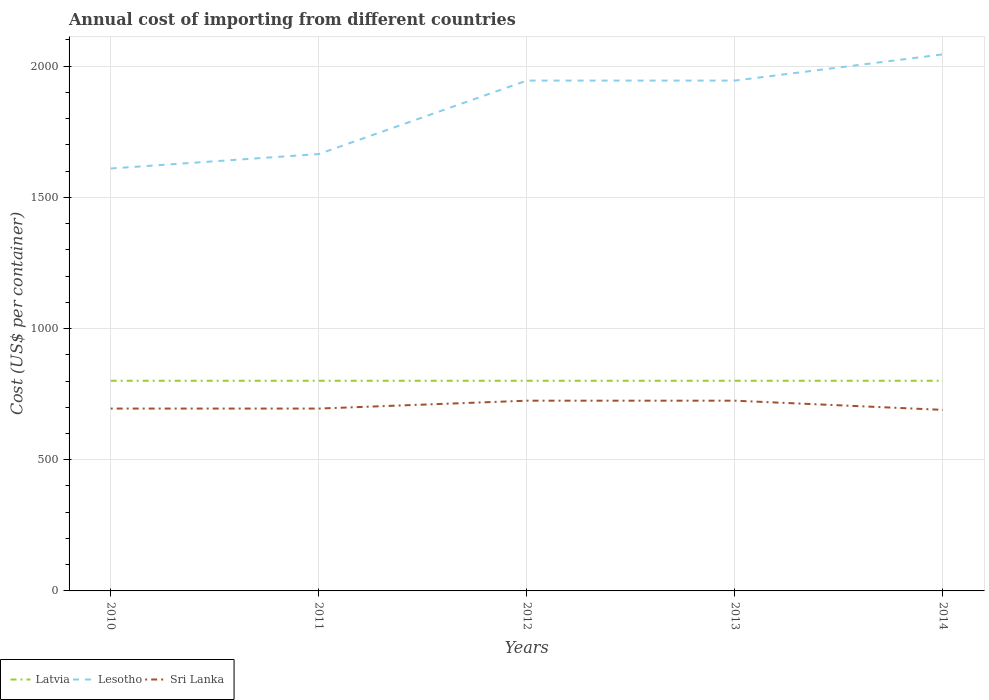How many different coloured lines are there?
Keep it short and to the point. 3. Across all years, what is the maximum total annual cost of importing in Latvia?
Your answer should be very brief. 801. What is the total total annual cost of importing in Sri Lanka in the graph?
Offer a terse response. 35. What is the difference between the highest and the second highest total annual cost of importing in Lesotho?
Your answer should be compact. 435. How many lines are there?
Make the answer very short. 3. Does the graph contain any zero values?
Your response must be concise. No. Where does the legend appear in the graph?
Give a very brief answer. Bottom left. How are the legend labels stacked?
Keep it short and to the point. Horizontal. What is the title of the graph?
Offer a terse response. Annual cost of importing from different countries. What is the label or title of the X-axis?
Provide a succinct answer. Years. What is the label or title of the Y-axis?
Your answer should be very brief. Cost (US$ per container). What is the Cost (US$ per container) of Latvia in 2010?
Provide a succinct answer. 801. What is the Cost (US$ per container) of Lesotho in 2010?
Keep it short and to the point. 1610. What is the Cost (US$ per container) in Sri Lanka in 2010?
Provide a short and direct response. 695. What is the Cost (US$ per container) of Latvia in 2011?
Make the answer very short. 801. What is the Cost (US$ per container) in Lesotho in 2011?
Provide a short and direct response. 1665. What is the Cost (US$ per container) of Sri Lanka in 2011?
Your response must be concise. 695. What is the Cost (US$ per container) in Latvia in 2012?
Your response must be concise. 801. What is the Cost (US$ per container) in Lesotho in 2012?
Your answer should be compact. 1945. What is the Cost (US$ per container) in Sri Lanka in 2012?
Ensure brevity in your answer.  725. What is the Cost (US$ per container) in Latvia in 2013?
Provide a short and direct response. 801. What is the Cost (US$ per container) of Lesotho in 2013?
Your response must be concise. 1945. What is the Cost (US$ per container) of Sri Lanka in 2013?
Ensure brevity in your answer.  725. What is the Cost (US$ per container) of Latvia in 2014?
Make the answer very short. 801. What is the Cost (US$ per container) of Lesotho in 2014?
Offer a terse response. 2045. What is the Cost (US$ per container) of Sri Lanka in 2014?
Keep it short and to the point. 690. Across all years, what is the maximum Cost (US$ per container) in Latvia?
Provide a succinct answer. 801. Across all years, what is the maximum Cost (US$ per container) of Lesotho?
Your answer should be compact. 2045. Across all years, what is the maximum Cost (US$ per container) of Sri Lanka?
Offer a very short reply. 725. Across all years, what is the minimum Cost (US$ per container) of Latvia?
Ensure brevity in your answer.  801. Across all years, what is the minimum Cost (US$ per container) of Lesotho?
Keep it short and to the point. 1610. Across all years, what is the minimum Cost (US$ per container) in Sri Lanka?
Provide a short and direct response. 690. What is the total Cost (US$ per container) in Latvia in the graph?
Keep it short and to the point. 4005. What is the total Cost (US$ per container) in Lesotho in the graph?
Ensure brevity in your answer.  9210. What is the total Cost (US$ per container) of Sri Lanka in the graph?
Your response must be concise. 3530. What is the difference between the Cost (US$ per container) in Lesotho in 2010 and that in 2011?
Make the answer very short. -55. What is the difference between the Cost (US$ per container) of Lesotho in 2010 and that in 2012?
Make the answer very short. -335. What is the difference between the Cost (US$ per container) in Sri Lanka in 2010 and that in 2012?
Make the answer very short. -30. What is the difference between the Cost (US$ per container) in Latvia in 2010 and that in 2013?
Offer a terse response. 0. What is the difference between the Cost (US$ per container) in Lesotho in 2010 and that in 2013?
Offer a terse response. -335. What is the difference between the Cost (US$ per container) of Sri Lanka in 2010 and that in 2013?
Your answer should be compact. -30. What is the difference between the Cost (US$ per container) in Latvia in 2010 and that in 2014?
Provide a short and direct response. 0. What is the difference between the Cost (US$ per container) of Lesotho in 2010 and that in 2014?
Keep it short and to the point. -435. What is the difference between the Cost (US$ per container) of Sri Lanka in 2010 and that in 2014?
Give a very brief answer. 5. What is the difference between the Cost (US$ per container) of Latvia in 2011 and that in 2012?
Provide a short and direct response. 0. What is the difference between the Cost (US$ per container) of Lesotho in 2011 and that in 2012?
Your answer should be very brief. -280. What is the difference between the Cost (US$ per container) of Sri Lanka in 2011 and that in 2012?
Your answer should be very brief. -30. What is the difference between the Cost (US$ per container) in Lesotho in 2011 and that in 2013?
Provide a succinct answer. -280. What is the difference between the Cost (US$ per container) in Latvia in 2011 and that in 2014?
Make the answer very short. 0. What is the difference between the Cost (US$ per container) in Lesotho in 2011 and that in 2014?
Keep it short and to the point. -380. What is the difference between the Cost (US$ per container) in Sri Lanka in 2011 and that in 2014?
Your answer should be very brief. 5. What is the difference between the Cost (US$ per container) in Latvia in 2012 and that in 2013?
Offer a very short reply. 0. What is the difference between the Cost (US$ per container) in Lesotho in 2012 and that in 2013?
Your response must be concise. 0. What is the difference between the Cost (US$ per container) in Latvia in 2012 and that in 2014?
Make the answer very short. 0. What is the difference between the Cost (US$ per container) of Lesotho in 2012 and that in 2014?
Ensure brevity in your answer.  -100. What is the difference between the Cost (US$ per container) in Sri Lanka in 2012 and that in 2014?
Your answer should be very brief. 35. What is the difference between the Cost (US$ per container) of Latvia in 2013 and that in 2014?
Provide a succinct answer. 0. What is the difference between the Cost (US$ per container) of Lesotho in 2013 and that in 2014?
Give a very brief answer. -100. What is the difference between the Cost (US$ per container) in Latvia in 2010 and the Cost (US$ per container) in Lesotho in 2011?
Provide a succinct answer. -864. What is the difference between the Cost (US$ per container) of Latvia in 2010 and the Cost (US$ per container) of Sri Lanka in 2011?
Ensure brevity in your answer.  106. What is the difference between the Cost (US$ per container) of Lesotho in 2010 and the Cost (US$ per container) of Sri Lanka in 2011?
Provide a succinct answer. 915. What is the difference between the Cost (US$ per container) in Latvia in 2010 and the Cost (US$ per container) in Lesotho in 2012?
Offer a very short reply. -1144. What is the difference between the Cost (US$ per container) in Latvia in 2010 and the Cost (US$ per container) in Sri Lanka in 2012?
Give a very brief answer. 76. What is the difference between the Cost (US$ per container) in Lesotho in 2010 and the Cost (US$ per container) in Sri Lanka in 2012?
Offer a terse response. 885. What is the difference between the Cost (US$ per container) of Latvia in 2010 and the Cost (US$ per container) of Lesotho in 2013?
Give a very brief answer. -1144. What is the difference between the Cost (US$ per container) in Latvia in 2010 and the Cost (US$ per container) in Sri Lanka in 2013?
Your answer should be compact. 76. What is the difference between the Cost (US$ per container) in Lesotho in 2010 and the Cost (US$ per container) in Sri Lanka in 2013?
Your response must be concise. 885. What is the difference between the Cost (US$ per container) of Latvia in 2010 and the Cost (US$ per container) of Lesotho in 2014?
Offer a very short reply. -1244. What is the difference between the Cost (US$ per container) in Latvia in 2010 and the Cost (US$ per container) in Sri Lanka in 2014?
Offer a terse response. 111. What is the difference between the Cost (US$ per container) of Lesotho in 2010 and the Cost (US$ per container) of Sri Lanka in 2014?
Your answer should be very brief. 920. What is the difference between the Cost (US$ per container) of Latvia in 2011 and the Cost (US$ per container) of Lesotho in 2012?
Your response must be concise. -1144. What is the difference between the Cost (US$ per container) of Lesotho in 2011 and the Cost (US$ per container) of Sri Lanka in 2012?
Offer a very short reply. 940. What is the difference between the Cost (US$ per container) in Latvia in 2011 and the Cost (US$ per container) in Lesotho in 2013?
Provide a short and direct response. -1144. What is the difference between the Cost (US$ per container) of Latvia in 2011 and the Cost (US$ per container) of Sri Lanka in 2013?
Give a very brief answer. 76. What is the difference between the Cost (US$ per container) in Lesotho in 2011 and the Cost (US$ per container) in Sri Lanka in 2013?
Provide a short and direct response. 940. What is the difference between the Cost (US$ per container) of Latvia in 2011 and the Cost (US$ per container) of Lesotho in 2014?
Ensure brevity in your answer.  -1244. What is the difference between the Cost (US$ per container) of Latvia in 2011 and the Cost (US$ per container) of Sri Lanka in 2014?
Provide a succinct answer. 111. What is the difference between the Cost (US$ per container) in Lesotho in 2011 and the Cost (US$ per container) in Sri Lanka in 2014?
Your answer should be compact. 975. What is the difference between the Cost (US$ per container) in Latvia in 2012 and the Cost (US$ per container) in Lesotho in 2013?
Provide a succinct answer. -1144. What is the difference between the Cost (US$ per container) of Lesotho in 2012 and the Cost (US$ per container) of Sri Lanka in 2013?
Your response must be concise. 1220. What is the difference between the Cost (US$ per container) in Latvia in 2012 and the Cost (US$ per container) in Lesotho in 2014?
Your answer should be compact. -1244. What is the difference between the Cost (US$ per container) of Latvia in 2012 and the Cost (US$ per container) of Sri Lanka in 2014?
Keep it short and to the point. 111. What is the difference between the Cost (US$ per container) of Lesotho in 2012 and the Cost (US$ per container) of Sri Lanka in 2014?
Your answer should be very brief. 1255. What is the difference between the Cost (US$ per container) in Latvia in 2013 and the Cost (US$ per container) in Lesotho in 2014?
Ensure brevity in your answer.  -1244. What is the difference between the Cost (US$ per container) of Latvia in 2013 and the Cost (US$ per container) of Sri Lanka in 2014?
Keep it short and to the point. 111. What is the difference between the Cost (US$ per container) of Lesotho in 2013 and the Cost (US$ per container) of Sri Lanka in 2014?
Keep it short and to the point. 1255. What is the average Cost (US$ per container) in Latvia per year?
Your response must be concise. 801. What is the average Cost (US$ per container) in Lesotho per year?
Your answer should be compact. 1842. What is the average Cost (US$ per container) in Sri Lanka per year?
Your answer should be compact. 706. In the year 2010, what is the difference between the Cost (US$ per container) in Latvia and Cost (US$ per container) in Lesotho?
Offer a very short reply. -809. In the year 2010, what is the difference between the Cost (US$ per container) in Latvia and Cost (US$ per container) in Sri Lanka?
Provide a short and direct response. 106. In the year 2010, what is the difference between the Cost (US$ per container) of Lesotho and Cost (US$ per container) of Sri Lanka?
Your response must be concise. 915. In the year 2011, what is the difference between the Cost (US$ per container) of Latvia and Cost (US$ per container) of Lesotho?
Provide a short and direct response. -864. In the year 2011, what is the difference between the Cost (US$ per container) of Latvia and Cost (US$ per container) of Sri Lanka?
Give a very brief answer. 106. In the year 2011, what is the difference between the Cost (US$ per container) in Lesotho and Cost (US$ per container) in Sri Lanka?
Your answer should be very brief. 970. In the year 2012, what is the difference between the Cost (US$ per container) of Latvia and Cost (US$ per container) of Lesotho?
Your answer should be very brief. -1144. In the year 2012, what is the difference between the Cost (US$ per container) in Latvia and Cost (US$ per container) in Sri Lanka?
Give a very brief answer. 76. In the year 2012, what is the difference between the Cost (US$ per container) in Lesotho and Cost (US$ per container) in Sri Lanka?
Keep it short and to the point. 1220. In the year 2013, what is the difference between the Cost (US$ per container) in Latvia and Cost (US$ per container) in Lesotho?
Offer a very short reply. -1144. In the year 2013, what is the difference between the Cost (US$ per container) of Latvia and Cost (US$ per container) of Sri Lanka?
Make the answer very short. 76. In the year 2013, what is the difference between the Cost (US$ per container) of Lesotho and Cost (US$ per container) of Sri Lanka?
Offer a very short reply. 1220. In the year 2014, what is the difference between the Cost (US$ per container) of Latvia and Cost (US$ per container) of Lesotho?
Ensure brevity in your answer.  -1244. In the year 2014, what is the difference between the Cost (US$ per container) of Latvia and Cost (US$ per container) of Sri Lanka?
Make the answer very short. 111. In the year 2014, what is the difference between the Cost (US$ per container) of Lesotho and Cost (US$ per container) of Sri Lanka?
Ensure brevity in your answer.  1355. What is the ratio of the Cost (US$ per container) in Latvia in 2010 to that in 2011?
Provide a short and direct response. 1. What is the ratio of the Cost (US$ per container) of Lesotho in 2010 to that in 2011?
Your answer should be compact. 0.97. What is the ratio of the Cost (US$ per container) of Sri Lanka in 2010 to that in 2011?
Offer a terse response. 1. What is the ratio of the Cost (US$ per container) in Latvia in 2010 to that in 2012?
Provide a succinct answer. 1. What is the ratio of the Cost (US$ per container) of Lesotho in 2010 to that in 2012?
Your answer should be very brief. 0.83. What is the ratio of the Cost (US$ per container) in Sri Lanka in 2010 to that in 2012?
Your answer should be compact. 0.96. What is the ratio of the Cost (US$ per container) of Lesotho in 2010 to that in 2013?
Make the answer very short. 0.83. What is the ratio of the Cost (US$ per container) in Sri Lanka in 2010 to that in 2013?
Provide a succinct answer. 0.96. What is the ratio of the Cost (US$ per container) in Lesotho in 2010 to that in 2014?
Offer a very short reply. 0.79. What is the ratio of the Cost (US$ per container) in Sri Lanka in 2010 to that in 2014?
Keep it short and to the point. 1.01. What is the ratio of the Cost (US$ per container) in Latvia in 2011 to that in 2012?
Provide a short and direct response. 1. What is the ratio of the Cost (US$ per container) in Lesotho in 2011 to that in 2012?
Make the answer very short. 0.86. What is the ratio of the Cost (US$ per container) of Sri Lanka in 2011 to that in 2012?
Your response must be concise. 0.96. What is the ratio of the Cost (US$ per container) in Lesotho in 2011 to that in 2013?
Your answer should be very brief. 0.86. What is the ratio of the Cost (US$ per container) of Sri Lanka in 2011 to that in 2013?
Your answer should be very brief. 0.96. What is the ratio of the Cost (US$ per container) of Lesotho in 2011 to that in 2014?
Offer a terse response. 0.81. What is the ratio of the Cost (US$ per container) in Lesotho in 2012 to that in 2013?
Provide a short and direct response. 1. What is the ratio of the Cost (US$ per container) in Sri Lanka in 2012 to that in 2013?
Provide a short and direct response. 1. What is the ratio of the Cost (US$ per container) in Latvia in 2012 to that in 2014?
Make the answer very short. 1. What is the ratio of the Cost (US$ per container) in Lesotho in 2012 to that in 2014?
Make the answer very short. 0.95. What is the ratio of the Cost (US$ per container) of Sri Lanka in 2012 to that in 2014?
Keep it short and to the point. 1.05. What is the ratio of the Cost (US$ per container) of Latvia in 2013 to that in 2014?
Make the answer very short. 1. What is the ratio of the Cost (US$ per container) in Lesotho in 2013 to that in 2014?
Give a very brief answer. 0.95. What is the ratio of the Cost (US$ per container) of Sri Lanka in 2013 to that in 2014?
Offer a very short reply. 1.05. What is the difference between the highest and the second highest Cost (US$ per container) in Lesotho?
Your response must be concise. 100. What is the difference between the highest and the lowest Cost (US$ per container) of Latvia?
Your answer should be compact. 0. What is the difference between the highest and the lowest Cost (US$ per container) in Lesotho?
Offer a very short reply. 435. What is the difference between the highest and the lowest Cost (US$ per container) in Sri Lanka?
Ensure brevity in your answer.  35. 